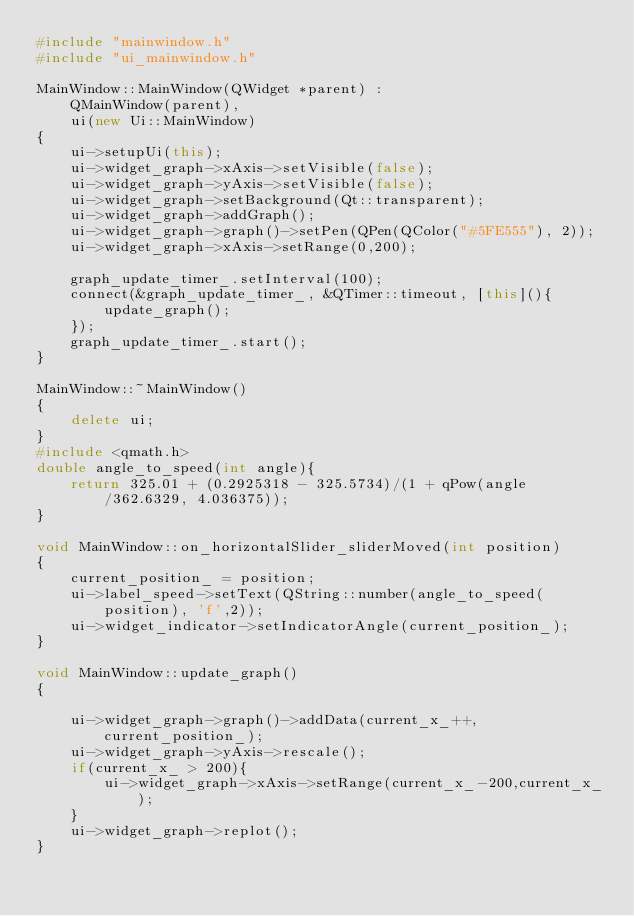Convert code to text. <code><loc_0><loc_0><loc_500><loc_500><_C++_>#include "mainwindow.h"
#include "ui_mainwindow.h"

MainWindow::MainWindow(QWidget *parent) :
    QMainWindow(parent),
    ui(new Ui::MainWindow)
{
    ui->setupUi(this);
    ui->widget_graph->xAxis->setVisible(false);
    ui->widget_graph->yAxis->setVisible(false);
    ui->widget_graph->setBackground(Qt::transparent);
    ui->widget_graph->addGraph();
    ui->widget_graph->graph()->setPen(QPen(QColor("#5FE555"), 2));
    ui->widget_graph->xAxis->setRange(0,200);

    graph_update_timer_.setInterval(100);
    connect(&graph_update_timer_, &QTimer::timeout, [this](){
        update_graph();
    });
    graph_update_timer_.start();
}

MainWindow::~MainWindow()
{
    delete ui;
}
#include <qmath.h>
double angle_to_speed(int angle){
    return 325.01 + (0.2925318 - 325.5734)/(1 + qPow(angle/362.6329, 4.036375));
}

void MainWindow::on_horizontalSlider_sliderMoved(int position)
{
    current_position_ = position;
    ui->label_speed->setText(QString::number(angle_to_speed(position), 'f',2));
    ui->widget_indicator->setIndicatorAngle(current_position_);
}

void MainWindow::update_graph()
{

    ui->widget_graph->graph()->addData(current_x_++, current_position_);
    ui->widget_graph->yAxis->rescale();
    if(current_x_ > 200){
        ui->widget_graph->xAxis->setRange(current_x_-200,current_x_);
    }
    ui->widget_graph->replot();
}
</code> 